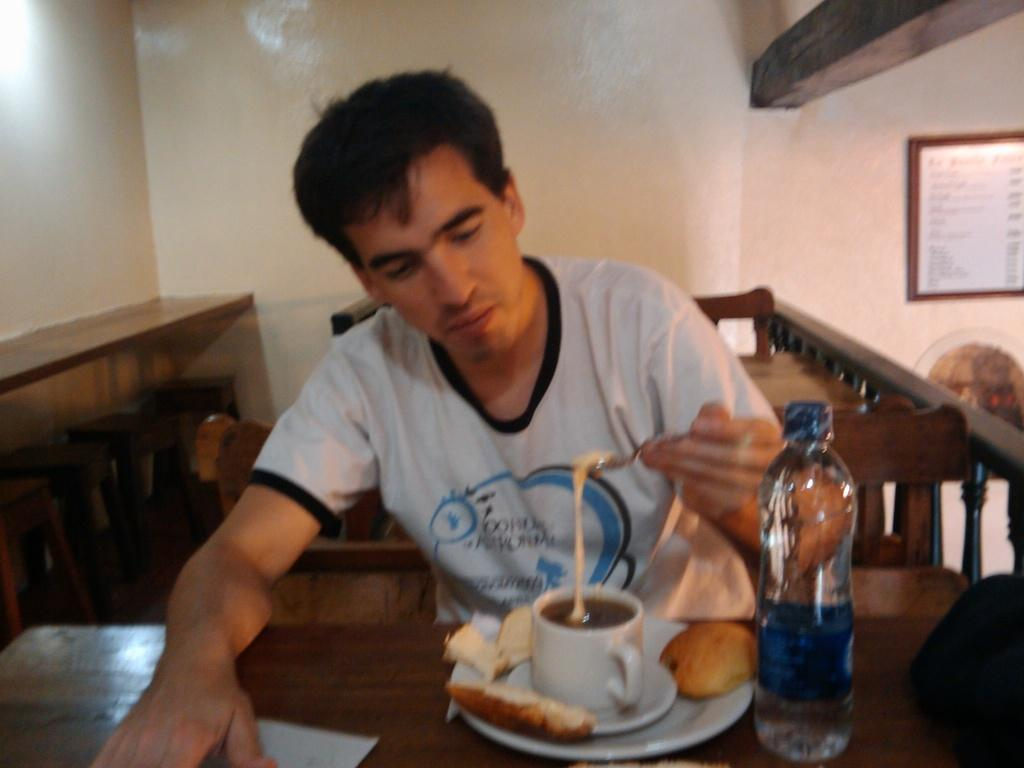What is the man in the image doing? The man is sitting in the image. What is the man holding in the image? The man is holding a spoon. What can be seen on the table in the image? There is a cup with a saucer, some bread, and a water bottle on the table. What is the price of the chess set in the image? There is no chess set present in the image, so it is not possible to determine its price. 